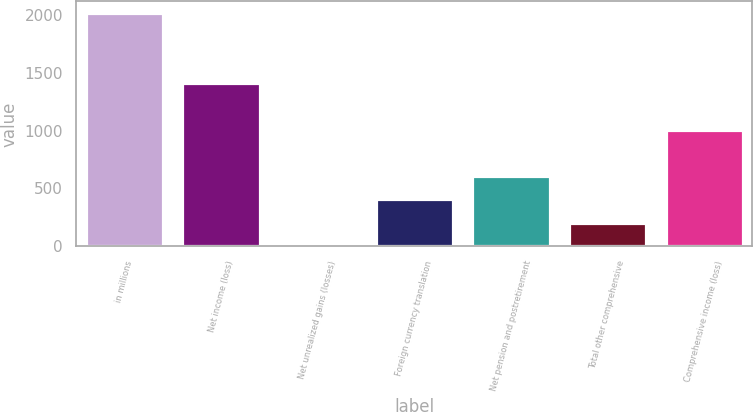Convert chart to OTSL. <chart><loc_0><loc_0><loc_500><loc_500><bar_chart><fcel>in millions<fcel>Net income (loss)<fcel>Net unrealized gains (losses)<fcel>Foreign currency translation<fcel>Net pension and postretirement<fcel>Total other comprehensive<fcel>Comprehensive income (loss)<nl><fcel>2014<fcel>1410.7<fcel>3<fcel>405.2<fcel>606.3<fcel>204.1<fcel>1008.5<nl></chart> 